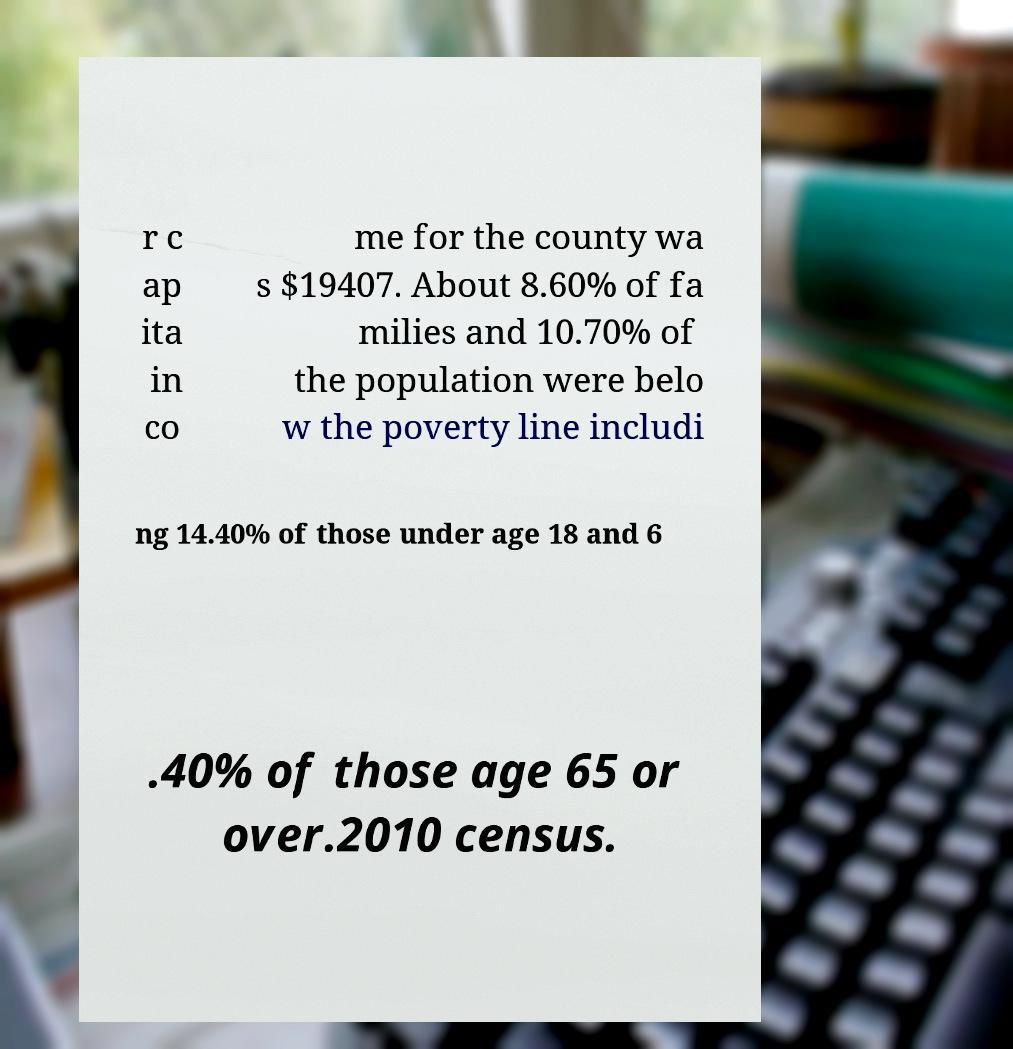Please identify and transcribe the text found in this image. r c ap ita in co me for the county wa s $19407. About 8.60% of fa milies and 10.70% of the population were belo w the poverty line includi ng 14.40% of those under age 18 and 6 .40% of those age 65 or over.2010 census. 